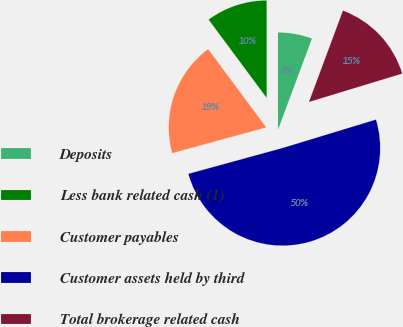Convert chart to OTSL. <chart><loc_0><loc_0><loc_500><loc_500><pie_chart><fcel>Deposits<fcel>Less bank related cash (1)<fcel>Customer payables<fcel>Customer assets held by third<fcel>Total brokerage related cash<nl><fcel>5.67%<fcel>10.15%<fcel>19.1%<fcel>50.44%<fcel>14.63%<nl></chart> 